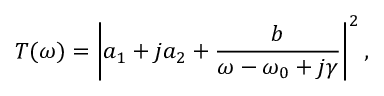<formula> <loc_0><loc_0><loc_500><loc_500>T ( \omega ) = \left | a _ { 1 } + j a _ { 2 } + \frac { b } { \omega - \omega _ { 0 } + j \gamma } \right | ^ { 2 } ,</formula> 